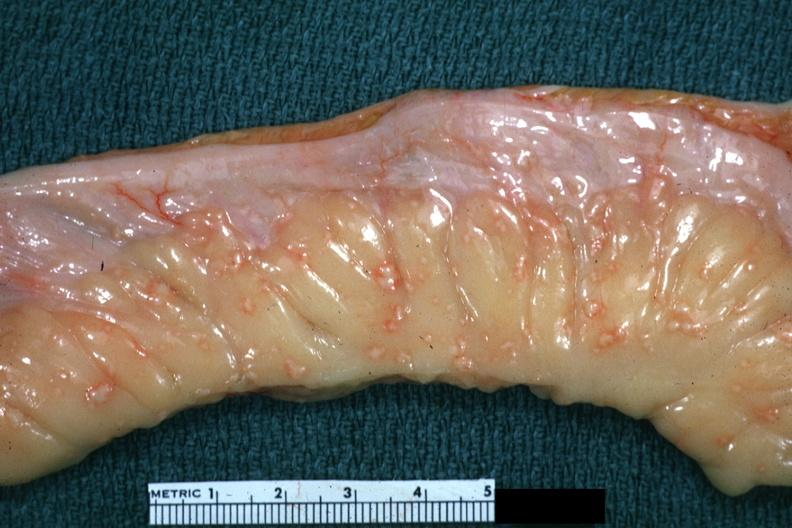s abdomen present?
Answer the question using a single word or phrase. Yes 